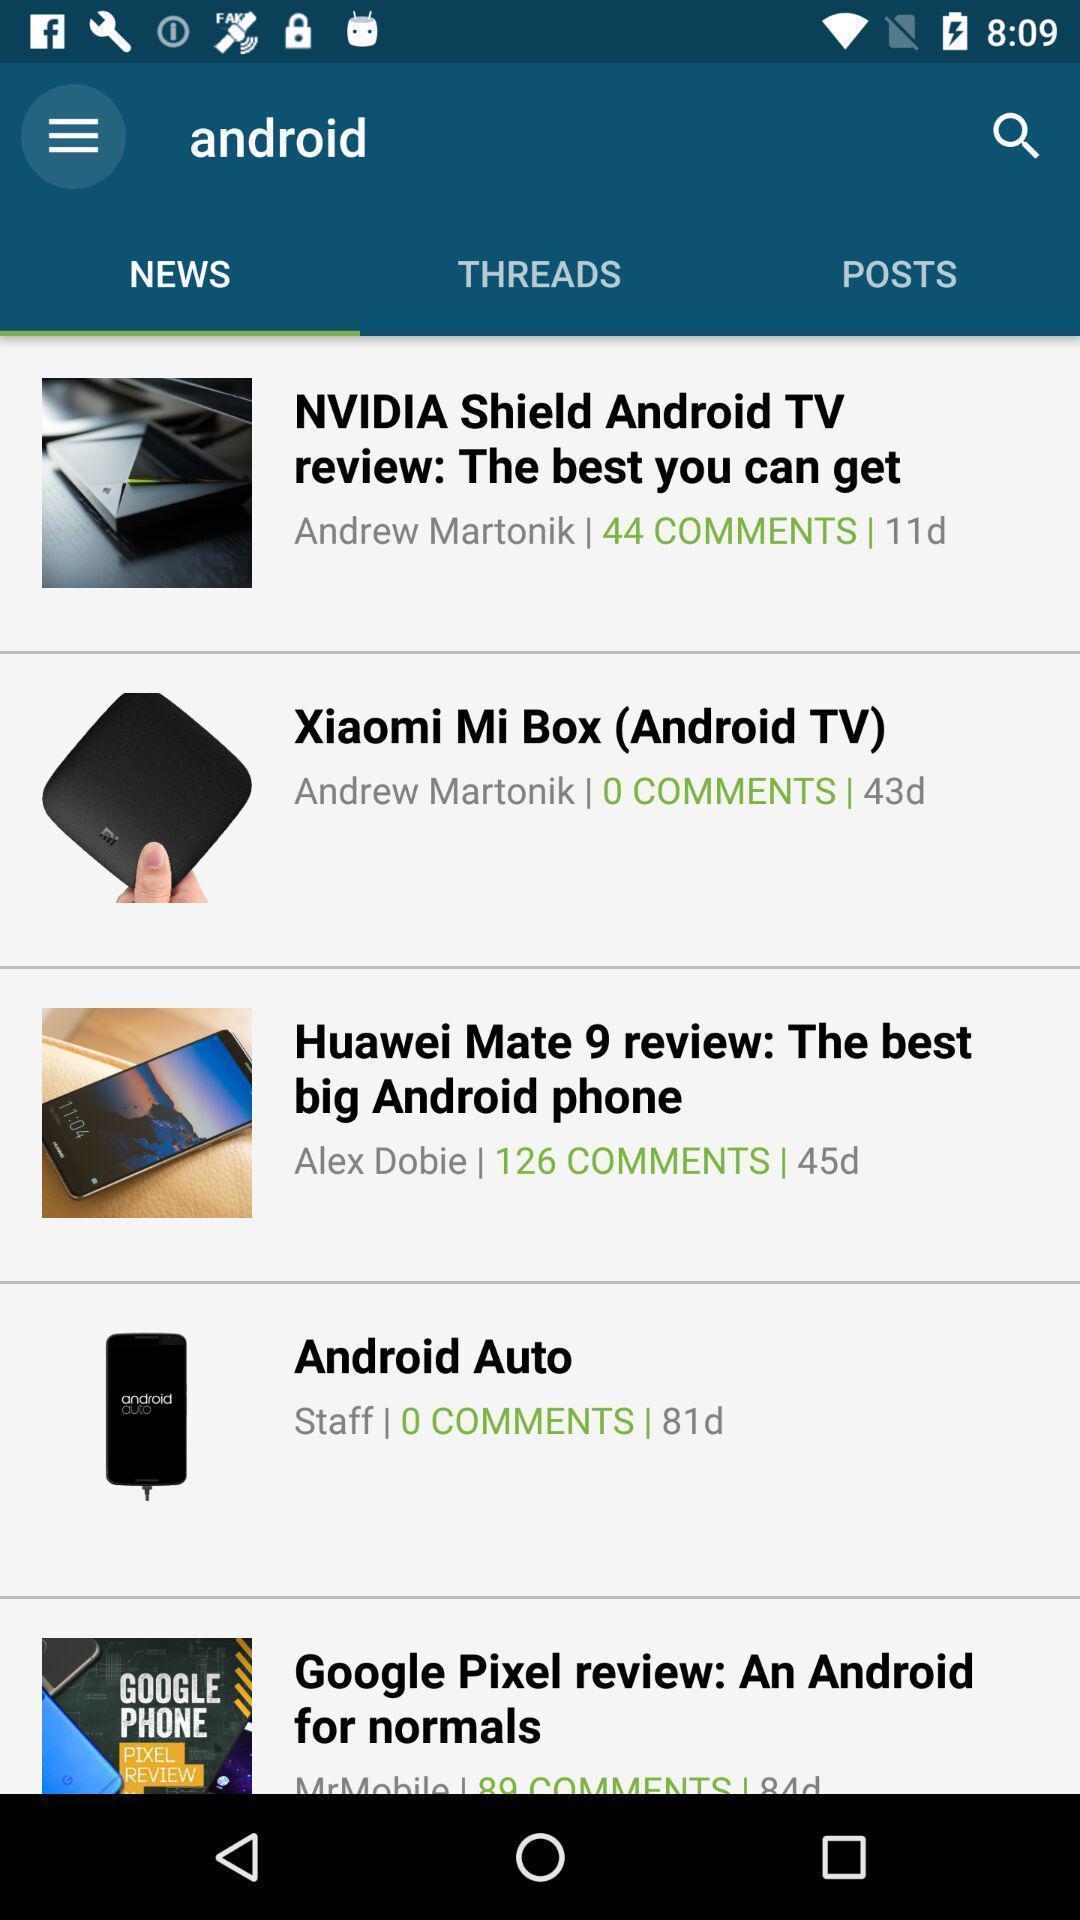Tell me what you see in this picture. Various news feed displayed. 